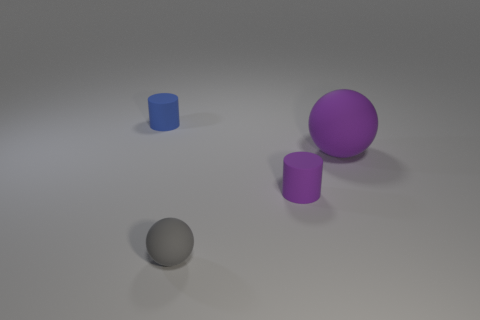Add 4 spheres. How many objects exist? 8 Subtract all purple spheres. How many spheres are left? 1 Subtract all gray cylinders. How many purple spheres are left? 1 Subtract all purple matte objects. Subtract all tiny gray matte objects. How many objects are left? 1 Add 2 small rubber cylinders. How many small rubber cylinders are left? 4 Add 1 tiny matte cylinders. How many tiny matte cylinders exist? 3 Subtract 0 yellow spheres. How many objects are left? 4 Subtract 1 cylinders. How many cylinders are left? 1 Subtract all cyan spheres. Subtract all brown cylinders. How many spheres are left? 2 